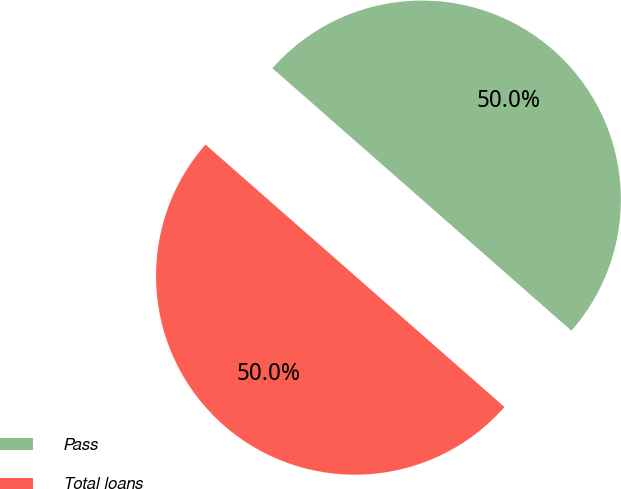Convert chart. <chart><loc_0><loc_0><loc_500><loc_500><pie_chart><fcel>Pass<fcel>Total loans<nl><fcel>50.0%<fcel>50.0%<nl></chart> 